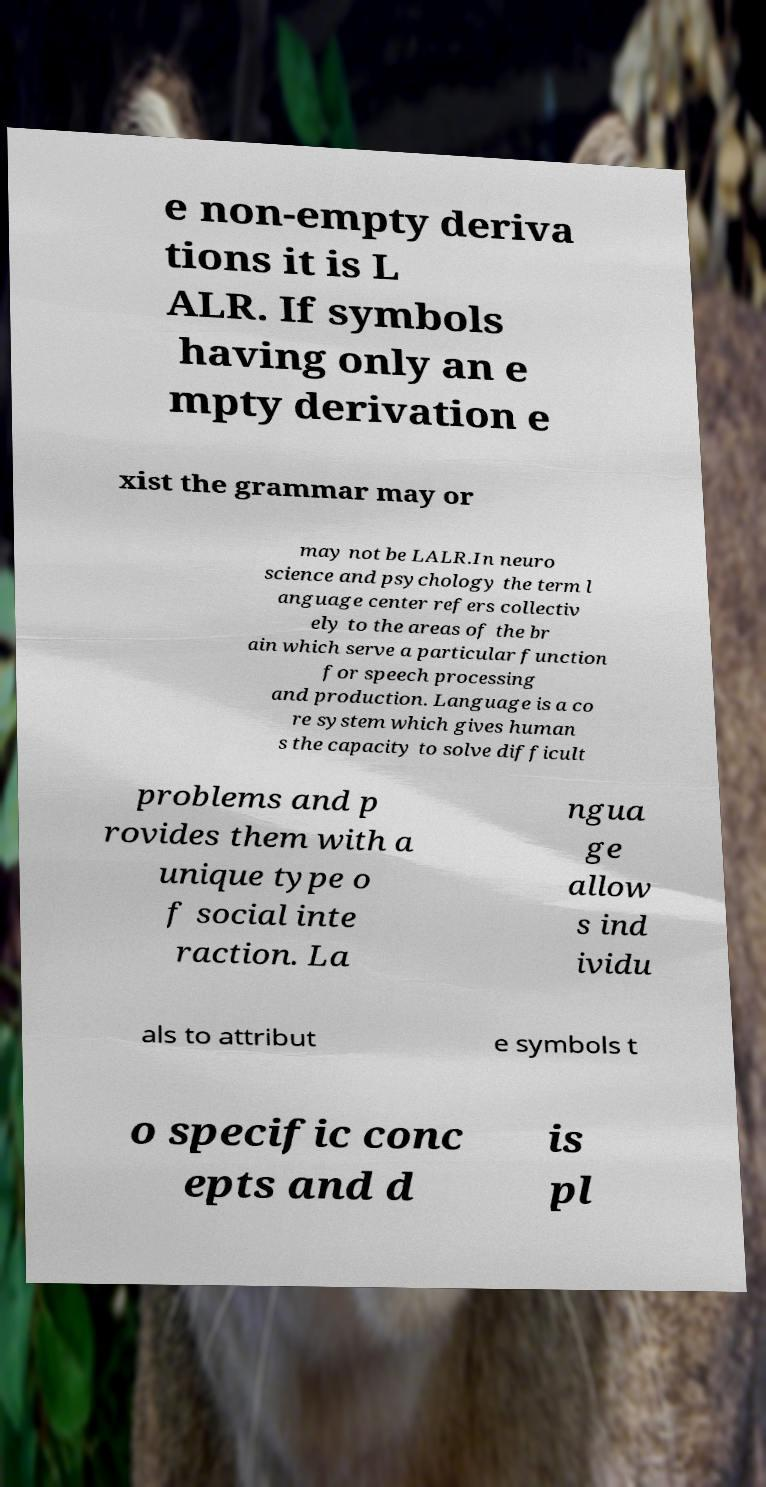Please identify and transcribe the text found in this image. e non-empty deriva tions it is L ALR. If symbols having only an e mpty derivation e xist the grammar may or may not be LALR.In neuro science and psychology the term l anguage center refers collectiv ely to the areas of the br ain which serve a particular function for speech processing and production. Language is a co re system which gives human s the capacity to solve difficult problems and p rovides them with a unique type o f social inte raction. La ngua ge allow s ind ividu als to attribut e symbols t o specific conc epts and d is pl 